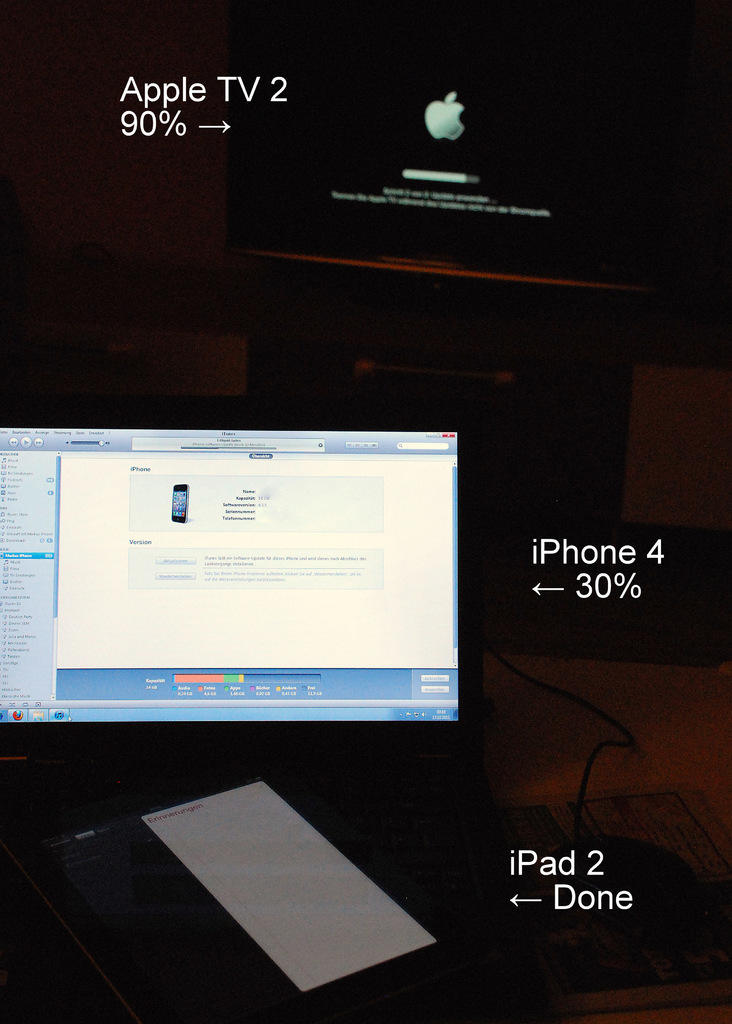Provide a one-sentence caption for the provided image. A setup showing various Apple devices including an iPhone 4 and iPad 2, with the Apple TV 2 undergoing an update, displayed across multiple screens, signifying a synchronization or update process. 